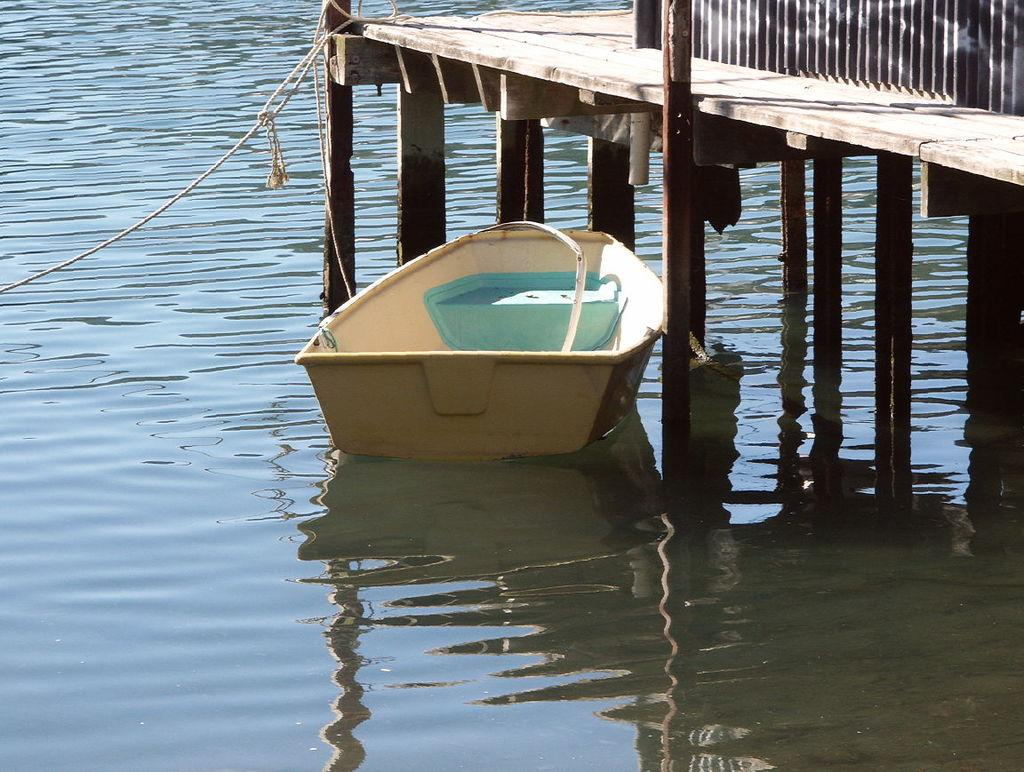What is in the water in the image? There is a boat in the water in the image. How is the boat secured in the water? The boat is tied with a rope. What object can be seen beside the boat? There is a metal rod beside the boat. What type of structure is visible in the image? There is a bridge in the image. Can you describe the flock of birds flying over the bridge in the image? There are no birds visible in the image; it only shows a boat in the water, a rope, a metal rod, and a bridge. 